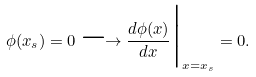Convert formula to latex. <formula><loc_0><loc_0><loc_500><loc_500>\phi ( x _ { s } ) = 0 \longrightarrow \frac { d \phi ( x ) } { d x } \Big { | } _ { x = x _ { s } } = 0 .</formula> 